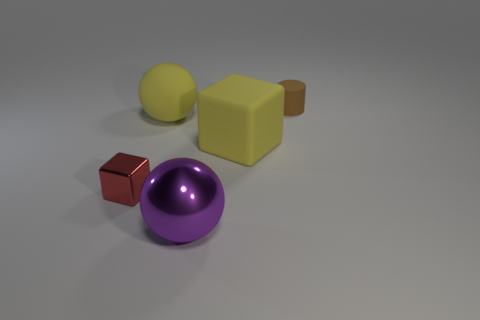The matte object that is the same color as the large cube is what shape?
Your response must be concise. Sphere. Are there the same number of small red metallic things behind the yellow sphere and small yellow rubber cylinders?
Keep it short and to the point. Yes. The small object to the left of the matte thing to the right of the large yellow object that is in front of the big yellow rubber sphere is made of what material?
Keep it short and to the point. Metal. The other big object that is the same material as the red thing is what shape?
Provide a succinct answer. Sphere. Is there any other thing of the same color as the large metal sphere?
Offer a very short reply. No. How many tiny brown rubber objects are to the right of the small object that is to the right of the yellow rubber object right of the big metal object?
Your response must be concise. 0. What number of brown things are matte cylinders or matte cubes?
Your answer should be very brief. 1. Does the purple metal thing have the same size as the yellow thing that is behind the yellow rubber block?
Provide a succinct answer. Yes. What material is the yellow thing that is the same shape as the purple metal thing?
Give a very brief answer. Rubber. What number of other objects are the same size as the red metal block?
Offer a very short reply. 1. 